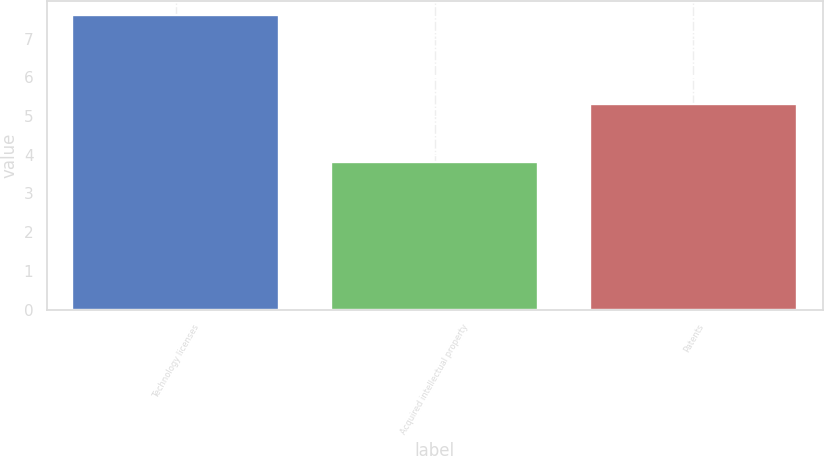<chart> <loc_0><loc_0><loc_500><loc_500><bar_chart><fcel>Technology licenses<fcel>Acquired intellectual property<fcel>Patents<nl><fcel>7.6<fcel>3.8<fcel>5.3<nl></chart> 